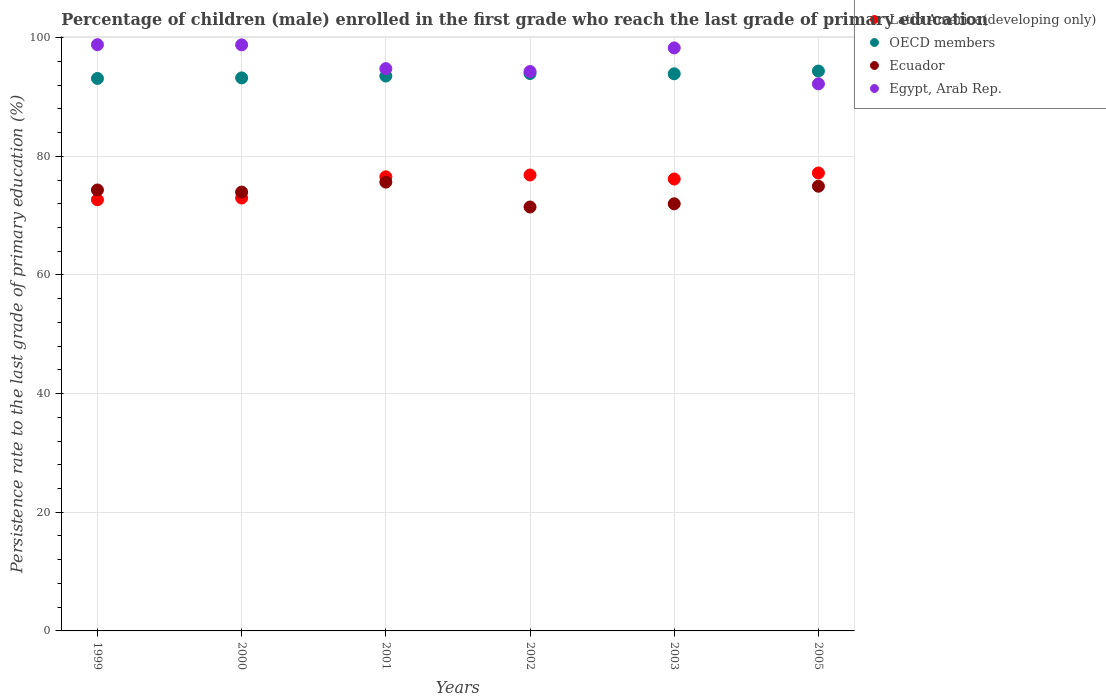How many different coloured dotlines are there?
Your response must be concise. 4. Is the number of dotlines equal to the number of legend labels?
Your answer should be very brief. Yes. What is the persistence rate of children in OECD members in 1999?
Keep it short and to the point. 93.12. Across all years, what is the maximum persistence rate of children in Latin America(developing only)?
Ensure brevity in your answer.  77.18. Across all years, what is the minimum persistence rate of children in Ecuador?
Keep it short and to the point. 71.45. In which year was the persistence rate of children in Egypt, Arab Rep. minimum?
Your answer should be very brief. 2005. What is the total persistence rate of children in Egypt, Arab Rep. in the graph?
Provide a succinct answer. 577.1. What is the difference between the persistence rate of children in Latin America(developing only) in 2001 and that in 2002?
Offer a very short reply. -0.3. What is the difference between the persistence rate of children in Latin America(developing only) in 2002 and the persistence rate of children in OECD members in 1999?
Offer a terse response. -16.27. What is the average persistence rate of children in OECD members per year?
Provide a succinct answer. 93.68. In the year 2000, what is the difference between the persistence rate of children in Egypt, Arab Rep. and persistence rate of children in Latin America(developing only)?
Offer a terse response. 25.81. What is the ratio of the persistence rate of children in Ecuador in 2001 to that in 2002?
Give a very brief answer. 1.06. Is the persistence rate of children in OECD members in 2000 less than that in 2002?
Offer a terse response. Yes. What is the difference between the highest and the second highest persistence rate of children in OECD members?
Give a very brief answer. 0.42. What is the difference between the highest and the lowest persistence rate of children in Egypt, Arab Rep.?
Your answer should be very brief. 6.61. Is it the case that in every year, the sum of the persistence rate of children in Egypt, Arab Rep. and persistence rate of children in OECD members  is greater than the sum of persistence rate of children in Ecuador and persistence rate of children in Latin America(developing only)?
Your answer should be compact. Yes. Is it the case that in every year, the sum of the persistence rate of children in Ecuador and persistence rate of children in OECD members  is greater than the persistence rate of children in Latin America(developing only)?
Make the answer very short. Yes. Does the persistence rate of children in Egypt, Arab Rep. monotonically increase over the years?
Provide a short and direct response. No. Are the values on the major ticks of Y-axis written in scientific E-notation?
Provide a short and direct response. No. Does the graph contain any zero values?
Make the answer very short. No. Does the graph contain grids?
Your response must be concise. Yes. Where does the legend appear in the graph?
Offer a very short reply. Top right. How are the legend labels stacked?
Provide a short and direct response. Vertical. What is the title of the graph?
Your answer should be compact. Percentage of children (male) enrolled in the first grade who reach the last grade of primary education. What is the label or title of the Y-axis?
Your answer should be compact. Persistence rate to the last grade of primary education (%). What is the Persistence rate to the last grade of primary education (%) in Latin America(developing only) in 1999?
Make the answer very short. 72.67. What is the Persistence rate to the last grade of primary education (%) in OECD members in 1999?
Offer a very short reply. 93.12. What is the Persistence rate to the last grade of primary education (%) of Ecuador in 1999?
Keep it short and to the point. 74.32. What is the Persistence rate to the last grade of primary education (%) in Egypt, Arab Rep. in 1999?
Your answer should be compact. 98.81. What is the Persistence rate to the last grade of primary education (%) in Latin America(developing only) in 2000?
Your answer should be very brief. 72.96. What is the Persistence rate to the last grade of primary education (%) in OECD members in 2000?
Offer a very short reply. 93.21. What is the Persistence rate to the last grade of primary education (%) in Ecuador in 2000?
Provide a short and direct response. 73.96. What is the Persistence rate to the last grade of primary education (%) of Egypt, Arab Rep. in 2000?
Your answer should be very brief. 98.78. What is the Persistence rate to the last grade of primary education (%) of Latin America(developing only) in 2001?
Your answer should be compact. 76.54. What is the Persistence rate to the last grade of primary education (%) in OECD members in 2001?
Your response must be concise. 93.52. What is the Persistence rate to the last grade of primary education (%) of Ecuador in 2001?
Make the answer very short. 75.64. What is the Persistence rate to the last grade of primary education (%) of Egypt, Arab Rep. in 2001?
Offer a terse response. 94.77. What is the Persistence rate to the last grade of primary education (%) in Latin America(developing only) in 2002?
Offer a terse response. 76.84. What is the Persistence rate to the last grade of primary education (%) in OECD members in 2002?
Keep it short and to the point. 93.95. What is the Persistence rate to the last grade of primary education (%) in Ecuador in 2002?
Give a very brief answer. 71.45. What is the Persistence rate to the last grade of primary education (%) of Egypt, Arab Rep. in 2002?
Give a very brief answer. 94.28. What is the Persistence rate to the last grade of primary education (%) in Latin America(developing only) in 2003?
Make the answer very short. 76.17. What is the Persistence rate to the last grade of primary education (%) of OECD members in 2003?
Your response must be concise. 93.9. What is the Persistence rate to the last grade of primary education (%) in Ecuador in 2003?
Provide a short and direct response. 71.99. What is the Persistence rate to the last grade of primary education (%) of Egypt, Arab Rep. in 2003?
Provide a succinct answer. 98.26. What is the Persistence rate to the last grade of primary education (%) in Latin America(developing only) in 2005?
Provide a succinct answer. 77.18. What is the Persistence rate to the last grade of primary education (%) in OECD members in 2005?
Your answer should be compact. 94.36. What is the Persistence rate to the last grade of primary education (%) in Ecuador in 2005?
Keep it short and to the point. 74.95. What is the Persistence rate to the last grade of primary education (%) of Egypt, Arab Rep. in 2005?
Your answer should be compact. 92.2. Across all years, what is the maximum Persistence rate to the last grade of primary education (%) in Latin America(developing only)?
Provide a succinct answer. 77.18. Across all years, what is the maximum Persistence rate to the last grade of primary education (%) in OECD members?
Ensure brevity in your answer.  94.36. Across all years, what is the maximum Persistence rate to the last grade of primary education (%) in Ecuador?
Provide a succinct answer. 75.64. Across all years, what is the maximum Persistence rate to the last grade of primary education (%) of Egypt, Arab Rep.?
Give a very brief answer. 98.81. Across all years, what is the minimum Persistence rate to the last grade of primary education (%) of Latin America(developing only)?
Offer a terse response. 72.67. Across all years, what is the minimum Persistence rate to the last grade of primary education (%) in OECD members?
Provide a short and direct response. 93.12. Across all years, what is the minimum Persistence rate to the last grade of primary education (%) of Ecuador?
Keep it short and to the point. 71.45. Across all years, what is the minimum Persistence rate to the last grade of primary education (%) of Egypt, Arab Rep.?
Keep it short and to the point. 92.2. What is the total Persistence rate to the last grade of primary education (%) in Latin America(developing only) in the graph?
Give a very brief answer. 452.36. What is the total Persistence rate to the last grade of primary education (%) in OECD members in the graph?
Provide a succinct answer. 562.05. What is the total Persistence rate to the last grade of primary education (%) in Ecuador in the graph?
Offer a very short reply. 442.32. What is the total Persistence rate to the last grade of primary education (%) in Egypt, Arab Rep. in the graph?
Your answer should be very brief. 577.1. What is the difference between the Persistence rate to the last grade of primary education (%) in Latin America(developing only) in 1999 and that in 2000?
Ensure brevity in your answer.  -0.3. What is the difference between the Persistence rate to the last grade of primary education (%) of OECD members in 1999 and that in 2000?
Offer a very short reply. -0.09. What is the difference between the Persistence rate to the last grade of primary education (%) in Ecuador in 1999 and that in 2000?
Provide a succinct answer. 0.35. What is the difference between the Persistence rate to the last grade of primary education (%) in Egypt, Arab Rep. in 1999 and that in 2000?
Your answer should be very brief. 0.03. What is the difference between the Persistence rate to the last grade of primary education (%) in Latin America(developing only) in 1999 and that in 2001?
Offer a very short reply. -3.87. What is the difference between the Persistence rate to the last grade of primary education (%) in OECD members in 1999 and that in 2001?
Ensure brevity in your answer.  -0.41. What is the difference between the Persistence rate to the last grade of primary education (%) of Ecuador in 1999 and that in 2001?
Give a very brief answer. -1.33. What is the difference between the Persistence rate to the last grade of primary education (%) in Egypt, Arab Rep. in 1999 and that in 2001?
Provide a short and direct response. 4.04. What is the difference between the Persistence rate to the last grade of primary education (%) of Latin America(developing only) in 1999 and that in 2002?
Your answer should be very brief. -4.18. What is the difference between the Persistence rate to the last grade of primary education (%) of OECD members in 1999 and that in 2002?
Your answer should be very brief. -0.83. What is the difference between the Persistence rate to the last grade of primary education (%) of Ecuador in 1999 and that in 2002?
Give a very brief answer. 2.87. What is the difference between the Persistence rate to the last grade of primary education (%) in Egypt, Arab Rep. in 1999 and that in 2002?
Your answer should be very brief. 4.52. What is the difference between the Persistence rate to the last grade of primary education (%) of Latin America(developing only) in 1999 and that in 2003?
Offer a very short reply. -3.5. What is the difference between the Persistence rate to the last grade of primary education (%) in OECD members in 1999 and that in 2003?
Offer a terse response. -0.78. What is the difference between the Persistence rate to the last grade of primary education (%) in Ecuador in 1999 and that in 2003?
Provide a short and direct response. 2.33. What is the difference between the Persistence rate to the last grade of primary education (%) of Egypt, Arab Rep. in 1999 and that in 2003?
Ensure brevity in your answer.  0.54. What is the difference between the Persistence rate to the last grade of primary education (%) of Latin America(developing only) in 1999 and that in 2005?
Provide a succinct answer. -4.51. What is the difference between the Persistence rate to the last grade of primary education (%) of OECD members in 1999 and that in 2005?
Give a very brief answer. -1.25. What is the difference between the Persistence rate to the last grade of primary education (%) of Ecuador in 1999 and that in 2005?
Give a very brief answer. -0.63. What is the difference between the Persistence rate to the last grade of primary education (%) in Egypt, Arab Rep. in 1999 and that in 2005?
Make the answer very short. 6.61. What is the difference between the Persistence rate to the last grade of primary education (%) of Latin America(developing only) in 2000 and that in 2001?
Make the answer very short. -3.58. What is the difference between the Persistence rate to the last grade of primary education (%) in OECD members in 2000 and that in 2001?
Make the answer very short. -0.31. What is the difference between the Persistence rate to the last grade of primary education (%) in Ecuador in 2000 and that in 2001?
Your answer should be compact. -1.68. What is the difference between the Persistence rate to the last grade of primary education (%) of Egypt, Arab Rep. in 2000 and that in 2001?
Provide a succinct answer. 4.01. What is the difference between the Persistence rate to the last grade of primary education (%) in Latin America(developing only) in 2000 and that in 2002?
Ensure brevity in your answer.  -3.88. What is the difference between the Persistence rate to the last grade of primary education (%) of OECD members in 2000 and that in 2002?
Provide a succinct answer. -0.74. What is the difference between the Persistence rate to the last grade of primary education (%) in Ecuador in 2000 and that in 2002?
Your response must be concise. 2.52. What is the difference between the Persistence rate to the last grade of primary education (%) in Egypt, Arab Rep. in 2000 and that in 2002?
Offer a very short reply. 4.49. What is the difference between the Persistence rate to the last grade of primary education (%) in Latin America(developing only) in 2000 and that in 2003?
Your response must be concise. -3.2. What is the difference between the Persistence rate to the last grade of primary education (%) of OECD members in 2000 and that in 2003?
Offer a terse response. -0.69. What is the difference between the Persistence rate to the last grade of primary education (%) of Ecuador in 2000 and that in 2003?
Provide a succinct answer. 1.98. What is the difference between the Persistence rate to the last grade of primary education (%) in Egypt, Arab Rep. in 2000 and that in 2003?
Provide a succinct answer. 0.52. What is the difference between the Persistence rate to the last grade of primary education (%) in Latin America(developing only) in 2000 and that in 2005?
Make the answer very short. -4.22. What is the difference between the Persistence rate to the last grade of primary education (%) in OECD members in 2000 and that in 2005?
Your answer should be compact. -1.15. What is the difference between the Persistence rate to the last grade of primary education (%) in Ecuador in 2000 and that in 2005?
Make the answer very short. -0.99. What is the difference between the Persistence rate to the last grade of primary education (%) in Egypt, Arab Rep. in 2000 and that in 2005?
Give a very brief answer. 6.58. What is the difference between the Persistence rate to the last grade of primary education (%) in Latin America(developing only) in 2001 and that in 2002?
Provide a succinct answer. -0.3. What is the difference between the Persistence rate to the last grade of primary education (%) of OECD members in 2001 and that in 2002?
Give a very brief answer. -0.43. What is the difference between the Persistence rate to the last grade of primary education (%) of Ecuador in 2001 and that in 2002?
Give a very brief answer. 4.2. What is the difference between the Persistence rate to the last grade of primary education (%) of Egypt, Arab Rep. in 2001 and that in 2002?
Your answer should be very brief. 0.49. What is the difference between the Persistence rate to the last grade of primary education (%) of Latin America(developing only) in 2001 and that in 2003?
Offer a very short reply. 0.37. What is the difference between the Persistence rate to the last grade of primary education (%) in OECD members in 2001 and that in 2003?
Ensure brevity in your answer.  -0.38. What is the difference between the Persistence rate to the last grade of primary education (%) of Ecuador in 2001 and that in 2003?
Make the answer very short. 3.66. What is the difference between the Persistence rate to the last grade of primary education (%) in Egypt, Arab Rep. in 2001 and that in 2003?
Provide a succinct answer. -3.49. What is the difference between the Persistence rate to the last grade of primary education (%) of Latin America(developing only) in 2001 and that in 2005?
Your answer should be compact. -0.64. What is the difference between the Persistence rate to the last grade of primary education (%) in OECD members in 2001 and that in 2005?
Give a very brief answer. -0.84. What is the difference between the Persistence rate to the last grade of primary education (%) of Ecuador in 2001 and that in 2005?
Keep it short and to the point. 0.69. What is the difference between the Persistence rate to the last grade of primary education (%) of Egypt, Arab Rep. in 2001 and that in 2005?
Make the answer very short. 2.57. What is the difference between the Persistence rate to the last grade of primary education (%) in Latin America(developing only) in 2002 and that in 2003?
Keep it short and to the point. 0.68. What is the difference between the Persistence rate to the last grade of primary education (%) in OECD members in 2002 and that in 2003?
Keep it short and to the point. 0.05. What is the difference between the Persistence rate to the last grade of primary education (%) in Ecuador in 2002 and that in 2003?
Your answer should be compact. -0.54. What is the difference between the Persistence rate to the last grade of primary education (%) of Egypt, Arab Rep. in 2002 and that in 2003?
Give a very brief answer. -3.98. What is the difference between the Persistence rate to the last grade of primary education (%) of Latin America(developing only) in 2002 and that in 2005?
Ensure brevity in your answer.  -0.34. What is the difference between the Persistence rate to the last grade of primary education (%) in OECD members in 2002 and that in 2005?
Keep it short and to the point. -0.42. What is the difference between the Persistence rate to the last grade of primary education (%) of Ecuador in 2002 and that in 2005?
Offer a very short reply. -3.5. What is the difference between the Persistence rate to the last grade of primary education (%) of Egypt, Arab Rep. in 2002 and that in 2005?
Give a very brief answer. 2.08. What is the difference between the Persistence rate to the last grade of primary education (%) in Latin America(developing only) in 2003 and that in 2005?
Make the answer very short. -1.02. What is the difference between the Persistence rate to the last grade of primary education (%) of OECD members in 2003 and that in 2005?
Offer a very short reply. -0.46. What is the difference between the Persistence rate to the last grade of primary education (%) in Ecuador in 2003 and that in 2005?
Offer a very short reply. -2.96. What is the difference between the Persistence rate to the last grade of primary education (%) in Egypt, Arab Rep. in 2003 and that in 2005?
Your response must be concise. 6.06. What is the difference between the Persistence rate to the last grade of primary education (%) of Latin America(developing only) in 1999 and the Persistence rate to the last grade of primary education (%) of OECD members in 2000?
Your answer should be very brief. -20.54. What is the difference between the Persistence rate to the last grade of primary education (%) of Latin America(developing only) in 1999 and the Persistence rate to the last grade of primary education (%) of Ecuador in 2000?
Offer a very short reply. -1.3. What is the difference between the Persistence rate to the last grade of primary education (%) in Latin America(developing only) in 1999 and the Persistence rate to the last grade of primary education (%) in Egypt, Arab Rep. in 2000?
Your answer should be very brief. -26.11. What is the difference between the Persistence rate to the last grade of primary education (%) in OECD members in 1999 and the Persistence rate to the last grade of primary education (%) in Ecuador in 2000?
Provide a succinct answer. 19.15. What is the difference between the Persistence rate to the last grade of primary education (%) of OECD members in 1999 and the Persistence rate to the last grade of primary education (%) of Egypt, Arab Rep. in 2000?
Your answer should be very brief. -5.66. What is the difference between the Persistence rate to the last grade of primary education (%) in Ecuador in 1999 and the Persistence rate to the last grade of primary education (%) in Egypt, Arab Rep. in 2000?
Give a very brief answer. -24.46. What is the difference between the Persistence rate to the last grade of primary education (%) in Latin America(developing only) in 1999 and the Persistence rate to the last grade of primary education (%) in OECD members in 2001?
Provide a succinct answer. -20.85. What is the difference between the Persistence rate to the last grade of primary education (%) of Latin America(developing only) in 1999 and the Persistence rate to the last grade of primary education (%) of Ecuador in 2001?
Keep it short and to the point. -2.98. What is the difference between the Persistence rate to the last grade of primary education (%) in Latin America(developing only) in 1999 and the Persistence rate to the last grade of primary education (%) in Egypt, Arab Rep. in 2001?
Give a very brief answer. -22.1. What is the difference between the Persistence rate to the last grade of primary education (%) of OECD members in 1999 and the Persistence rate to the last grade of primary education (%) of Ecuador in 2001?
Provide a short and direct response. 17.47. What is the difference between the Persistence rate to the last grade of primary education (%) of OECD members in 1999 and the Persistence rate to the last grade of primary education (%) of Egypt, Arab Rep. in 2001?
Give a very brief answer. -1.66. What is the difference between the Persistence rate to the last grade of primary education (%) in Ecuador in 1999 and the Persistence rate to the last grade of primary education (%) in Egypt, Arab Rep. in 2001?
Your response must be concise. -20.45. What is the difference between the Persistence rate to the last grade of primary education (%) in Latin America(developing only) in 1999 and the Persistence rate to the last grade of primary education (%) in OECD members in 2002?
Your response must be concise. -21.28. What is the difference between the Persistence rate to the last grade of primary education (%) in Latin America(developing only) in 1999 and the Persistence rate to the last grade of primary education (%) in Ecuador in 2002?
Provide a succinct answer. 1.22. What is the difference between the Persistence rate to the last grade of primary education (%) of Latin America(developing only) in 1999 and the Persistence rate to the last grade of primary education (%) of Egypt, Arab Rep. in 2002?
Make the answer very short. -21.62. What is the difference between the Persistence rate to the last grade of primary education (%) in OECD members in 1999 and the Persistence rate to the last grade of primary education (%) in Ecuador in 2002?
Provide a succinct answer. 21.67. What is the difference between the Persistence rate to the last grade of primary education (%) of OECD members in 1999 and the Persistence rate to the last grade of primary education (%) of Egypt, Arab Rep. in 2002?
Provide a short and direct response. -1.17. What is the difference between the Persistence rate to the last grade of primary education (%) of Ecuador in 1999 and the Persistence rate to the last grade of primary education (%) of Egypt, Arab Rep. in 2002?
Provide a short and direct response. -19.96. What is the difference between the Persistence rate to the last grade of primary education (%) in Latin America(developing only) in 1999 and the Persistence rate to the last grade of primary education (%) in OECD members in 2003?
Your answer should be very brief. -21.23. What is the difference between the Persistence rate to the last grade of primary education (%) of Latin America(developing only) in 1999 and the Persistence rate to the last grade of primary education (%) of Ecuador in 2003?
Your response must be concise. 0.68. What is the difference between the Persistence rate to the last grade of primary education (%) in Latin America(developing only) in 1999 and the Persistence rate to the last grade of primary education (%) in Egypt, Arab Rep. in 2003?
Your response must be concise. -25.59. What is the difference between the Persistence rate to the last grade of primary education (%) in OECD members in 1999 and the Persistence rate to the last grade of primary education (%) in Ecuador in 2003?
Provide a succinct answer. 21.13. What is the difference between the Persistence rate to the last grade of primary education (%) of OECD members in 1999 and the Persistence rate to the last grade of primary education (%) of Egypt, Arab Rep. in 2003?
Make the answer very short. -5.15. What is the difference between the Persistence rate to the last grade of primary education (%) of Ecuador in 1999 and the Persistence rate to the last grade of primary education (%) of Egypt, Arab Rep. in 2003?
Ensure brevity in your answer.  -23.94. What is the difference between the Persistence rate to the last grade of primary education (%) in Latin America(developing only) in 1999 and the Persistence rate to the last grade of primary education (%) in OECD members in 2005?
Give a very brief answer. -21.7. What is the difference between the Persistence rate to the last grade of primary education (%) of Latin America(developing only) in 1999 and the Persistence rate to the last grade of primary education (%) of Ecuador in 2005?
Make the answer very short. -2.29. What is the difference between the Persistence rate to the last grade of primary education (%) of Latin America(developing only) in 1999 and the Persistence rate to the last grade of primary education (%) of Egypt, Arab Rep. in 2005?
Provide a short and direct response. -19.53. What is the difference between the Persistence rate to the last grade of primary education (%) of OECD members in 1999 and the Persistence rate to the last grade of primary education (%) of Ecuador in 2005?
Provide a short and direct response. 18.16. What is the difference between the Persistence rate to the last grade of primary education (%) in OECD members in 1999 and the Persistence rate to the last grade of primary education (%) in Egypt, Arab Rep. in 2005?
Make the answer very short. 0.91. What is the difference between the Persistence rate to the last grade of primary education (%) of Ecuador in 1999 and the Persistence rate to the last grade of primary education (%) of Egypt, Arab Rep. in 2005?
Offer a terse response. -17.88. What is the difference between the Persistence rate to the last grade of primary education (%) in Latin America(developing only) in 2000 and the Persistence rate to the last grade of primary education (%) in OECD members in 2001?
Ensure brevity in your answer.  -20.56. What is the difference between the Persistence rate to the last grade of primary education (%) of Latin America(developing only) in 2000 and the Persistence rate to the last grade of primary education (%) of Ecuador in 2001?
Make the answer very short. -2.68. What is the difference between the Persistence rate to the last grade of primary education (%) of Latin America(developing only) in 2000 and the Persistence rate to the last grade of primary education (%) of Egypt, Arab Rep. in 2001?
Your answer should be very brief. -21.81. What is the difference between the Persistence rate to the last grade of primary education (%) of OECD members in 2000 and the Persistence rate to the last grade of primary education (%) of Ecuador in 2001?
Provide a short and direct response. 17.57. What is the difference between the Persistence rate to the last grade of primary education (%) in OECD members in 2000 and the Persistence rate to the last grade of primary education (%) in Egypt, Arab Rep. in 2001?
Give a very brief answer. -1.56. What is the difference between the Persistence rate to the last grade of primary education (%) in Ecuador in 2000 and the Persistence rate to the last grade of primary education (%) in Egypt, Arab Rep. in 2001?
Offer a very short reply. -20.81. What is the difference between the Persistence rate to the last grade of primary education (%) of Latin America(developing only) in 2000 and the Persistence rate to the last grade of primary education (%) of OECD members in 2002?
Provide a succinct answer. -20.98. What is the difference between the Persistence rate to the last grade of primary education (%) in Latin America(developing only) in 2000 and the Persistence rate to the last grade of primary education (%) in Ecuador in 2002?
Your response must be concise. 1.52. What is the difference between the Persistence rate to the last grade of primary education (%) of Latin America(developing only) in 2000 and the Persistence rate to the last grade of primary education (%) of Egypt, Arab Rep. in 2002?
Offer a terse response. -21.32. What is the difference between the Persistence rate to the last grade of primary education (%) of OECD members in 2000 and the Persistence rate to the last grade of primary education (%) of Ecuador in 2002?
Your answer should be compact. 21.76. What is the difference between the Persistence rate to the last grade of primary education (%) of OECD members in 2000 and the Persistence rate to the last grade of primary education (%) of Egypt, Arab Rep. in 2002?
Make the answer very short. -1.07. What is the difference between the Persistence rate to the last grade of primary education (%) of Ecuador in 2000 and the Persistence rate to the last grade of primary education (%) of Egypt, Arab Rep. in 2002?
Your response must be concise. -20.32. What is the difference between the Persistence rate to the last grade of primary education (%) in Latin America(developing only) in 2000 and the Persistence rate to the last grade of primary education (%) in OECD members in 2003?
Your answer should be very brief. -20.94. What is the difference between the Persistence rate to the last grade of primary education (%) in Latin America(developing only) in 2000 and the Persistence rate to the last grade of primary education (%) in Ecuador in 2003?
Ensure brevity in your answer.  0.98. What is the difference between the Persistence rate to the last grade of primary education (%) in Latin America(developing only) in 2000 and the Persistence rate to the last grade of primary education (%) in Egypt, Arab Rep. in 2003?
Offer a terse response. -25.3. What is the difference between the Persistence rate to the last grade of primary education (%) in OECD members in 2000 and the Persistence rate to the last grade of primary education (%) in Ecuador in 2003?
Offer a terse response. 21.22. What is the difference between the Persistence rate to the last grade of primary education (%) of OECD members in 2000 and the Persistence rate to the last grade of primary education (%) of Egypt, Arab Rep. in 2003?
Provide a short and direct response. -5.05. What is the difference between the Persistence rate to the last grade of primary education (%) in Ecuador in 2000 and the Persistence rate to the last grade of primary education (%) in Egypt, Arab Rep. in 2003?
Keep it short and to the point. -24.3. What is the difference between the Persistence rate to the last grade of primary education (%) of Latin America(developing only) in 2000 and the Persistence rate to the last grade of primary education (%) of OECD members in 2005?
Provide a succinct answer. -21.4. What is the difference between the Persistence rate to the last grade of primary education (%) in Latin America(developing only) in 2000 and the Persistence rate to the last grade of primary education (%) in Ecuador in 2005?
Ensure brevity in your answer.  -1.99. What is the difference between the Persistence rate to the last grade of primary education (%) in Latin America(developing only) in 2000 and the Persistence rate to the last grade of primary education (%) in Egypt, Arab Rep. in 2005?
Your response must be concise. -19.24. What is the difference between the Persistence rate to the last grade of primary education (%) in OECD members in 2000 and the Persistence rate to the last grade of primary education (%) in Ecuador in 2005?
Ensure brevity in your answer.  18.26. What is the difference between the Persistence rate to the last grade of primary education (%) of OECD members in 2000 and the Persistence rate to the last grade of primary education (%) of Egypt, Arab Rep. in 2005?
Offer a very short reply. 1.01. What is the difference between the Persistence rate to the last grade of primary education (%) in Ecuador in 2000 and the Persistence rate to the last grade of primary education (%) in Egypt, Arab Rep. in 2005?
Provide a succinct answer. -18.24. What is the difference between the Persistence rate to the last grade of primary education (%) in Latin America(developing only) in 2001 and the Persistence rate to the last grade of primary education (%) in OECD members in 2002?
Your answer should be compact. -17.41. What is the difference between the Persistence rate to the last grade of primary education (%) in Latin America(developing only) in 2001 and the Persistence rate to the last grade of primary education (%) in Ecuador in 2002?
Your answer should be compact. 5.09. What is the difference between the Persistence rate to the last grade of primary education (%) in Latin America(developing only) in 2001 and the Persistence rate to the last grade of primary education (%) in Egypt, Arab Rep. in 2002?
Keep it short and to the point. -17.74. What is the difference between the Persistence rate to the last grade of primary education (%) of OECD members in 2001 and the Persistence rate to the last grade of primary education (%) of Ecuador in 2002?
Provide a succinct answer. 22.07. What is the difference between the Persistence rate to the last grade of primary education (%) of OECD members in 2001 and the Persistence rate to the last grade of primary education (%) of Egypt, Arab Rep. in 2002?
Give a very brief answer. -0.76. What is the difference between the Persistence rate to the last grade of primary education (%) in Ecuador in 2001 and the Persistence rate to the last grade of primary education (%) in Egypt, Arab Rep. in 2002?
Ensure brevity in your answer.  -18.64. What is the difference between the Persistence rate to the last grade of primary education (%) of Latin America(developing only) in 2001 and the Persistence rate to the last grade of primary education (%) of OECD members in 2003?
Give a very brief answer. -17.36. What is the difference between the Persistence rate to the last grade of primary education (%) of Latin America(developing only) in 2001 and the Persistence rate to the last grade of primary education (%) of Ecuador in 2003?
Your answer should be compact. 4.55. What is the difference between the Persistence rate to the last grade of primary education (%) of Latin America(developing only) in 2001 and the Persistence rate to the last grade of primary education (%) of Egypt, Arab Rep. in 2003?
Provide a succinct answer. -21.72. What is the difference between the Persistence rate to the last grade of primary education (%) of OECD members in 2001 and the Persistence rate to the last grade of primary education (%) of Ecuador in 2003?
Your response must be concise. 21.53. What is the difference between the Persistence rate to the last grade of primary education (%) of OECD members in 2001 and the Persistence rate to the last grade of primary education (%) of Egypt, Arab Rep. in 2003?
Your answer should be very brief. -4.74. What is the difference between the Persistence rate to the last grade of primary education (%) in Ecuador in 2001 and the Persistence rate to the last grade of primary education (%) in Egypt, Arab Rep. in 2003?
Keep it short and to the point. -22.62. What is the difference between the Persistence rate to the last grade of primary education (%) of Latin America(developing only) in 2001 and the Persistence rate to the last grade of primary education (%) of OECD members in 2005?
Provide a succinct answer. -17.82. What is the difference between the Persistence rate to the last grade of primary education (%) of Latin America(developing only) in 2001 and the Persistence rate to the last grade of primary education (%) of Ecuador in 2005?
Offer a very short reply. 1.59. What is the difference between the Persistence rate to the last grade of primary education (%) in Latin America(developing only) in 2001 and the Persistence rate to the last grade of primary education (%) in Egypt, Arab Rep. in 2005?
Provide a succinct answer. -15.66. What is the difference between the Persistence rate to the last grade of primary education (%) in OECD members in 2001 and the Persistence rate to the last grade of primary education (%) in Ecuador in 2005?
Provide a short and direct response. 18.57. What is the difference between the Persistence rate to the last grade of primary education (%) of OECD members in 2001 and the Persistence rate to the last grade of primary education (%) of Egypt, Arab Rep. in 2005?
Your answer should be compact. 1.32. What is the difference between the Persistence rate to the last grade of primary education (%) in Ecuador in 2001 and the Persistence rate to the last grade of primary education (%) in Egypt, Arab Rep. in 2005?
Give a very brief answer. -16.56. What is the difference between the Persistence rate to the last grade of primary education (%) in Latin America(developing only) in 2002 and the Persistence rate to the last grade of primary education (%) in OECD members in 2003?
Provide a short and direct response. -17.06. What is the difference between the Persistence rate to the last grade of primary education (%) of Latin America(developing only) in 2002 and the Persistence rate to the last grade of primary education (%) of Ecuador in 2003?
Make the answer very short. 4.85. What is the difference between the Persistence rate to the last grade of primary education (%) of Latin America(developing only) in 2002 and the Persistence rate to the last grade of primary education (%) of Egypt, Arab Rep. in 2003?
Your response must be concise. -21.42. What is the difference between the Persistence rate to the last grade of primary education (%) of OECD members in 2002 and the Persistence rate to the last grade of primary education (%) of Ecuador in 2003?
Make the answer very short. 21.96. What is the difference between the Persistence rate to the last grade of primary education (%) in OECD members in 2002 and the Persistence rate to the last grade of primary education (%) in Egypt, Arab Rep. in 2003?
Offer a terse response. -4.31. What is the difference between the Persistence rate to the last grade of primary education (%) of Ecuador in 2002 and the Persistence rate to the last grade of primary education (%) of Egypt, Arab Rep. in 2003?
Provide a short and direct response. -26.81. What is the difference between the Persistence rate to the last grade of primary education (%) in Latin America(developing only) in 2002 and the Persistence rate to the last grade of primary education (%) in OECD members in 2005?
Your answer should be compact. -17.52. What is the difference between the Persistence rate to the last grade of primary education (%) in Latin America(developing only) in 2002 and the Persistence rate to the last grade of primary education (%) in Ecuador in 2005?
Your response must be concise. 1.89. What is the difference between the Persistence rate to the last grade of primary education (%) of Latin America(developing only) in 2002 and the Persistence rate to the last grade of primary education (%) of Egypt, Arab Rep. in 2005?
Offer a terse response. -15.36. What is the difference between the Persistence rate to the last grade of primary education (%) in OECD members in 2002 and the Persistence rate to the last grade of primary education (%) in Ecuador in 2005?
Provide a short and direct response. 18.99. What is the difference between the Persistence rate to the last grade of primary education (%) of OECD members in 2002 and the Persistence rate to the last grade of primary education (%) of Egypt, Arab Rep. in 2005?
Provide a succinct answer. 1.75. What is the difference between the Persistence rate to the last grade of primary education (%) of Ecuador in 2002 and the Persistence rate to the last grade of primary education (%) of Egypt, Arab Rep. in 2005?
Provide a short and direct response. -20.75. What is the difference between the Persistence rate to the last grade of primary education (%) in Latin America(developing only) in 2003 and the Persistence rate to the last grade of primary education (%) in OECD members in 2005?
Offer a terse response. -18.2. What is the difference between the Persistence rate to the last grade of primary education (%) of Latin America(developing only) in 2003 and the Persistence rate to the last grade of primary education (%) of Ecuador in 2005?
Offer a very short reply. 1.21. What is the difference between the Persistence rate to the last grade of primary education (%) of Latin America(developing only) in 2003 and the Persistence rate to the last grade of primary education (%) of Egypt, Arab Rep. in 2005?
Offer a very short reply. -16.04. What is the difference between the Persistence rate to the last grade of primary education (%) in OECD members in 2003 and the Persistence rate to the last grade of primary education (%) in Ecuador in 2005?
Provide a succinct answer. 18.95. What is the difference between the Persistence rate to the last grade of primary education (%) in OECD members in 2003 and the Persistence rate to the last grade of primary education (%) in Egypt, Arab Rep. in 2005?
Ensure brevity in your answer.  1.7. What is the difference between the Persistence rate to the last grade of primary education (%) in Ecuador in 2003 and the Persistence rate to the last grade of primary education (%) in Egypt, Arab Rep. in 2005?
Your response must be concise. -20.21. What is the average Persistence rate to the last grade of primary education (%) in Latin America(developing only) per year?
Ensure brevity in your answer.  75.39. What is the average Persistence rate to the last grade of primary education (%) of OECD members per year?
Provide a short and direct response. 93.68. What is the average Persistence rate to the last grade of primary education (%) of Ecuador per year?
Your response must be concise. 73.72. What is the average Persistence rate to the last grade of primary education (%) of Egypt, Arab Rep. per year?
Ensure brevity in your answer.  96.18. In the year 1999, what is the difference between the Persistence rate to the last grade of primary education (%) in Latin America(developing only) and Persistence rate to the last grade of primary education (%) in OECD members?
Your answer should be very brief. -20.45. In the year 1999, what is the difference between the Persistence rate to the last grade of primary education (%) in Latin America(developing only) and Persistence rate to the last grade of primary education (%) in Ecuador?
Make the answer very short. -1.65. In the year 1999, what is the difference between the Persistence rate to the last grade of primary education (%) of Latin America(developing only) and Persistence rate to the last grade of primary education (%) of Egypt, Arab Rep.?
Keep it short and to the point. -26.14. In the year 1999, what is the difference between the Persistence rate to the last grade of primary education (%) of OECD members and Persistence rate to the last grade of primary education (%) of Ecuador?
Offer a terse response. 18.8. In the year 1999, what is the difference between the Persistence rate to the last grade of primary education (%) of OECD members and Persistence rate to the last grade of primary education (%) of Egypt, Arab Rep.?
Your answer should be compact. -5.69. In the year 1999, what is the difference between the Persistence rate to the last grade of primary education (%) in Ecuador and Persistence rate to the last grade of primary education (%) in Egypt, Arab Rep.?
Provide a succinct answer. -24.49. In the year 2000, what is the difference between the Persistence rate to the last grade of primary education (%) of Latin America(developing only) and Persistence rate to the last grade of primary education (%) of OECD members?
Provide a short and direct response. -20.25. In the year 2000, what is the difference between the Persistence rate to the last grade of primary education (%) of Latin America(developing only) and Persistence rate to the last grade of primary education (%) of Egypt, Arab Rep.?
Make the answer very short. -25.81. In the year 2000, what is the difference between the Persistence rate to the last grade of primary education (%) in OECD members and Persistence rate to the last grade of primary education (%) in Ecuador?
Offer a terse response. 19.25. In the year 2000, what is the difference between the Persistence rate to the last grade of primary education (%) of OECD members and Persistence rate to the last grade of primary education (%) of Egypt, Arab Rep.?
Provide a short and direct response. -5.57. In the year 2000, what is the difference between the Persistence rate to the last grade of primary education (%) in Ecuador and Persistence rate to the last grade of primary education (%) in Egypt, Arab Rep.?
Ensure brevity in your answer.  -24.81. In the year 2001, what is the difference between the Persistence rate to the last grade of primary education (%) of Latin America(developing only) and Persistence rate to the last grade of primary education (%) of OECD members?
Provide a succinct answer. -16.98. In the year 2001, what is the difference between the Persistence rate to the last grade of primary education (%) in Latin America(developing only) and Persistence rate to the last grade of primary education (%) in Ecuador?
Provide a short and direct response. 0.9. In the year 2001, what is the difference between the Persistence rate to the last grade of primary education (%) of Latin America(developing only) and Persistence rate to the last grade of primary education (%) of Egypt, Arab Rep.?
Give a very brief answer. -18.23. In the year 2001, what is the difference between the Persistence rate to the last grade of primary education (%) of OECD members and Persistence rate to the last grade of primary education (%) of Ecuador?
Give a very brief answer. 17.88. In the year 2001, what is the difference between the Persistence rate to the last grade of primary education (%) of OECD members and Persistence rate to the last grade of primary education (%) of Egypt, Arab Rep.?
Offer a very short reply. -1.25. In the year 2001, what is the difference between the Persistence rate to the last grade of primary education (%) of Ecuador and Persistence rate to the last grade of primary education (%) of Egypt, Arab Rep.?
Your answer should be very brief. -19.13. In the year 2002, what is the difference between the Persistence rate to the last grade of primary education (%) in Latin America(developing only) and Persistence rate to the last grade of primary education (%) in OECD members?
Provide a succinct answer. -17.1. In the year 2002, what is the difference between the Persistence rate to the last grade of primary education (%) in Latin America(developing only) and Persistence rate to the last grade of primary education (%) in Ecuador?
Provide a short and direct response. 5.39. In the year 2002, what is the difference between the Persistence rate to the last grade of primary education (%) in Latin America(developing only) and Persistence rate to the last grade of primary education (%) in Egypt, Arab Rep.?
Your answer should be very brief. -17.44. In the year 2002, what is the difference between the Persistence rate to the last grade of primary education (%) in OECD members and Persistence rate to the last grade of primary education (%) in Ecuador?
Offer a very short reply. 22.5. In the year 2002, what is the difference between the Persistence rate to the last grade of primary education (%) of OECD members and Persistence rate to the last grade of primary education (%) of Egypt, Arab Rep.?
Provide a succinct answer. -0.34. In the year 2002, what is the difference between the Persistence rate to the last grade of primary education (%) in Ecuador and Persistence rate to the last grade of primary education (%) in Egypt, Arab Rep.?
Give a very brief answer. -22.83. In the year 2003, what is the difference between the Persistence rate to the last grade of primary education (%) of Latin America(developing only) and Persistence rate to the last grade of primary education (%) of OECD members?
Provide a short and direct response. -17.73. In the year 2003, what is the difference between the Persistence rate to the last grade of primary education (%) of Latin America(developing only) and Persistence rate to the last grade of primary education (%) of Ecuador?
Keep it short and to the point. 4.18. In the year 2003, what is the difference between the Persistence rate to the last grade of primary education (%) of Latin America(developing only) and Persistence rate to the last grade of primary education (%) of Egypt, Arab Rep.?
Your response must be concise. -22.1. In the year 2003, what is the difference between the Persistence rate to the last grade of primary education (%) in OECD members and Persistence rate to the last grade of primary education (%) in Ecuador?
Offer a terse response. 21.91. In the year 2003, what is the difference between the Persistence rate to the last grade of primary education (%) of OECD members and Persistence rate to the last grade of primary education (%) of Egypt, Arab Rep.?
Your answer should be compact. -4.36. In the year 2003, what is the difference between the Persistence rate to the last grade of primary education (%) in Ecuador and Persistence rate to the last grade of primary education (%) in Egypt, Arab Rep.?
Ensure brevity in your answer.  -26.27. In the year 2005, what is the difference between the Persistence rate to the last grade of primary education (%) of Latin America(developing only) and Persistence rate to the last grade of primary education (%) of OECD members?
Your response must be concise. -17.18. In the year 2005, what is the difference between the Persistence rate to the last grade of primary education (%) in Latin America(developing only) and Persistence rate to the last grade of primary education (%) in Ecuador?
Provide a succinct answer. 2.23. In the year 2005, what is the difference between the Persistence rate to the last grade of primary education (%) of Latin America(developing only) and Persistence rate to the last grade of primary education (%) of Egypt, Arab Rep.?
Give a very brief answer. -15.02. In the year 2005, what is the difference between the Persistence rate to the last grade of primary education (%) of OECD members and Persistence rate to the last grade of primary education (%) of Ecuador?
Your response must be concise. 19.41. In the year 2005, what is the difference between the Persistence rate to the last grade of primary education (%) of OECD members and Persistence rate to the last grade of primary education (%) of Egypt, Arab Rep.?
Give a very brief answer. 2.16. In the year 2005, what is the difference between the Persistence rate to the last grade of primary education (%) of Ecuador and Persistence rate to the last grade of primary education (%) of Egypt, Arab Rep.?
Keep it short and to the point. -17.25. What is the ratio of the Persistence rate to the last grade of primary education (%) in Latin America(developing only) in 1999 to that in 2000?
Your answer should be very brief. 1. What is the ratio of the Persistence rate to the last grade of primary education (%) of Latin America(developing only) in 1999 to that in 2001?
Your answer should be compact. 0.95. What is the ratio of the Persistence rate to the last grade of primary education (%) in Ecuador in 1999 to that in 2001?
Offer a very short reply. 0.98. What is the ratio of the Persistence rate to the last grade of primary education (%) in Egypt, Arab Rep. in 1999 to that in 2001?
Ensure brevity in your answer.  1.04. What is the ratio of the Persistence rate to the last grade of primary education (%) in Latin America(developing only) in 1999 to that in 2002?
Your response must be concise. 0.95. What is the ratio of the Persistence rate to the last grade of primary education (%) in OECD members in 1999 to that in 2002?
Provide a short and direct response. 0.99. What is the ratio of the Persistence rate to the last grade of primary education (%) in Ecuador in 1999 to that in 2002?
Ensure brevity in your answer.  1.04. What is the ratio of the Persistence rate to the last grade of primary education (%) of Egypt, Arab Rep. in 1999 to that in 2002?
Give a very brief answer. 1.05. What is the ratio of the Persistence rate to the last grade of primary education (%) of Latin America(developing only) in 1999 to that in 2003?
Offer a terse response. 0.95. What is the ratio of the Persistence rate to the last grade of primary education (%) in OECD members in 1999 to that in 2003?
Your answer should be very brief. 0.99. What is the ratio of the Persistence rate to the last grade of primary education (%) of Ecuador in 1999 to that in 2003?
Ensure brevity in your answer.  1.03. What is the ratio of the Persistence rate to the last grade of primary education (%) in Egypt, Arab Rep. in 1999 to that in 2003?
Provide a short and direct response. 1.01. What is the ratio of the Persistence rate to the last grade of primary education (%) in Latin America(developing only) in 1999 to that in 2005?
Your answer should be very brief. 0.94. What is the ratio of the Persistence rate to the last grade of primary education (%) in Ecuador in 1999 to that in 2005?
Offer a very short reply. 0.99. What is the ratio of the Persistence rate to the last grade of primary education (%) in Egypt, Arab Rep. in 1999 to that in 2005?
Your answer should be very brief. 1.07. What is the ratio of the Persistence rate to the last grade of primary education (%) of Latin America(developing only) in 2000 to that in 2001?
Make the answer very short. 0.95. What is the ratio of the Persistence rate to the last grade of primary education (%) of Ecuador in 2000 to that in 2001?
Make the answer very short. 0.98. What is the ratio of the Persistence rate to the last grade of primary education (%) in Egypt, Arab Rep. in 2000 to that in 2001?
Offer a very short reply. 1.04. What is the ratio of the Persistence rate to the last grade of primary education (%) of Latin America(developing only) in 2000 to that in 2002?
Offer a terse response. 0.95. What is the ratio of the Persistence rate to the last grade of primary education (%) of OECD members in 2000 to that in 2002?
Your answer should be very brief. 0.99. What is the ratio of the Persistence rate to the last grade of primary education (%) of Ecuador in 2000 to that in 2002?
Your answer should be compact. 1.04. What is the ratio of the Persistence rate to the last grade of primary education (%) of Egypt, Arab Rep. in 2000 to that in 2002?
Provide a succinct answer. 1.05. What is the ratio of the Persistence rate to the last grade of primary education (%) of Latin America(developing only) in 2000 to that in 2003?
Ensure brevity in your answer.  0.96. What is the ratio of the Persistence rate to the last grade of primary education (%) of Ecuador in 2000 to that in 2003?
Make the answer very short. 1.03. What is the ratio of the Persistence rate to the last grade of primary education (%) in Latin America(developing only) in 2000 to that in 2005?
Offer a very short reply. 0.95. What is the ratio of the Persistence rate to the last grade of primary education (%) in Ecuador in 2000 to that in 2005?
Keep it short and to the point. 0.99. What is the ratio of the Persistence rate to the last grade of primary education (%) of Egypt, Arab Rep. in 2000 to that in 2005?
Offer a very short reply. 1.07. What is the ratio of the Persistence rate to the last grade of primary education (%) in Latin America(developing only) in 2001 to that in 2002?
Offer a very short reply. 1. What is the ratio of the Persistence rate to the last grade of primary education (%) of Ecuador in 2001 to that in 2002?
Give a very brief answer. 1.06. What is the ratio of the Persistence rate to the last grade of primary education (%) of Latin America(developing only) in 2001 to that in 2003?
Make the answer very short. 1. What is the ratio of the Persistence rate to the last grade of primary education (%) of Ecuador in 2001 to that in 2003?
Offer a very short reply. 1.05. What is the ratio of the Persistence rate to the last grade of primary education (%) in Egypt, Arab Rep. in 2001 to that in 2003?
Your answer should be compact. 0.96. What is the ratio of the Persistence rate to the last grade of primary education (%) of Latin America(developing only) in 2001 to that in 2005?
Make the answer very short. 0.99. What is the ratio of the Persistence rate to the last grade of primary education (%) in OECD members in 2001 to that in 2005?
Your response must be concise. 0.99. What is the ratio of the Persistence rate to the last grade of primary education (%) in Ecuador in 2001 to that in 2005?
Your response must be concise. 1.01. What is the ratio of the Persistence rate to the last grade of primary education (%) in Egypt, Arab Rep. in 2001 to that in 2005?
Offer a very short reply. 1.03. What is the ratio of the Persistence rate to the last grade of primary education (%) of Latin America(developing only) in 2002 to that in 2003?
Your response must be concise. 1.01. What is the ratio of the Persistence rate to the last grade of primary education (%) of Ecuador in 2002 to that in 2003?
Provide a short and direct response. 0.99. What is the ratio of the Persistence rate to the last grade of primary education (%) in Egypt, Arab Rep. in 2002 to that in 2003?
Provide a succinct answer. 0.96. What is the ratio of the Persistence rate to the last grade of primary education (%) of Latin America(developing only) in 2002 to that in 2005?
Your answer should be very brief. 1. What is the ratio of the Persistence rate to the last grade of primary education (%) in Ecuador in 2002 to that in 2005?
Keep it short and to the point. 0.95. What is the ratio of the Persistence rate to the last grade of primary education (%) of Egypt, Arab Rep. in 2002 to that in 2005?
Provide a succinct answer. 1.02. What is the ratio of the Persistence rate to the last grade of primary education (%) of Latin America(developing only) in 2003 to that in 2005?
Your answer should be compact. 0.99. What is the ratio of the Persistence rate to the last grade of primary education (%) in OECD members in 2003 to that in 2005?
Ensure brevity in your answer.  1. What is the ratio of the Persistence rate to the last grade of primary education (%) of Ecuador in 2003 to that in 2005?
Offer a very short reply. 0.96. What is the ratio of the Persistence rate to the last grade of primary education (%) of Egypt, Arab Rep. in 2003 to that in 2005?
Make the answer very short. 1.07. What is the difference between the highest and the second highest Persistence rate to the last grade of primary education (%) of Latin America(developing only)?
Keep it short and to the point. 0.34. What is the difference between the highest and the second highest Persistence rate to the last grade of primary education (%) in OECD members?
Ensure brevity in your answer.  0.42. What is the difference between the highest and the second highest Persistence rate to the last grade of primary education (%) of Ecuador?
Give a very brief answer. 0.69. What is the difference between the highest and the second highest Persistence rate to the last grade of primary education (%) in Egypt, Arab Rep.?
Provide a short and direct response. 0.03. What is the difference between the highest and the lowest Persistence rate to the last grade of primary education (%) in Latin America(developing only)?
Offer a terse response. 4.51. What is the difference between the highest and the lowest Persistence rate to the last grade of primary education (%) of OECD members?
Your answer should be very brief. 1.25. What is the difference between the highest and the lowest Persistence rate to the last grade of primary education (%) of Ecuador?
Keep it short and to the point. 4.2. What is the difference between the highest and the lowest Persistence rate to the last grade of primary education (%) of Egypt, Arab Rep.?
Your answer should be very brief. 6.61. 